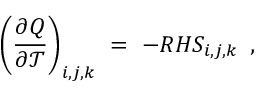<formula> <loc_0><loc_0><loc_500><loc_500>\left ( \frac { \partial Q } { \partial \mathcal { T } } \right ) _ { i , j , k } \ = \ - R H S _ { i , j , k } \, ,</formula> 